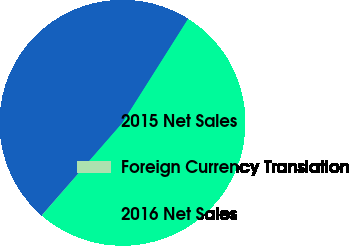<chart> <loc_0><loc_0><loc_500><loc_500><pie_chart><fcel>2015 Net Sales<fcel>Foreign Currency Translation<fcel>2016 Net Sales<nl><fcel>47.55%<fcel>0.04%<fcel>52.4%<nl></chart> 